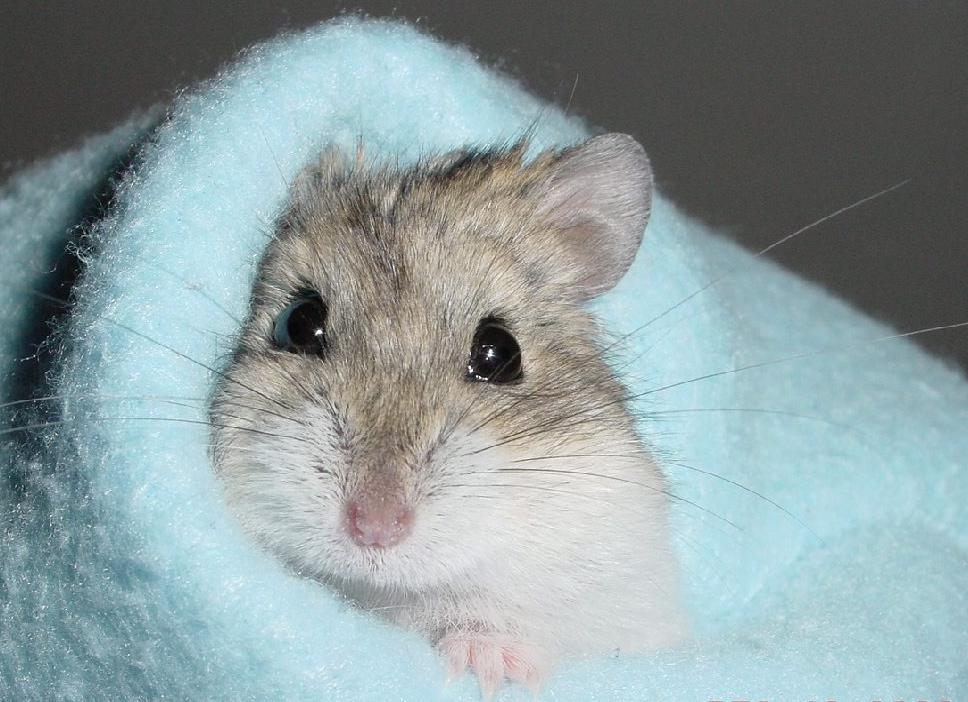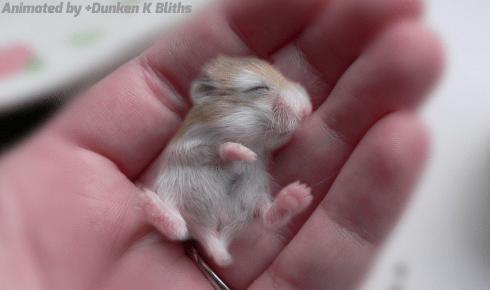The first image is the image on the left, the second image is the image on the right. For the images shown, is this caption "The right image contains a human hand holding a rodent." true? Answer yes or no. Yes. The first image is the image on the left, the second image is the image on the right. Evaluate the accuracy of this statement regarding the images: "A pet rodent is held in the palm of one hand in one image, and the other image shows a hamster looking mostly forward.". Is it true? Answer yes or no. Yes. 